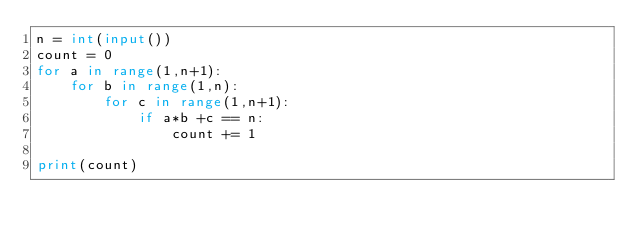<code> <loc_0><loc_0><loc_500><loc_500><_Python_>n = int(input())
count = 0
for a in range(1,n+1):
    for b in range(1,n):
        for c in range(1,n+1):
            if a*b +c == n:
                count += 1

print(count)
</code> 